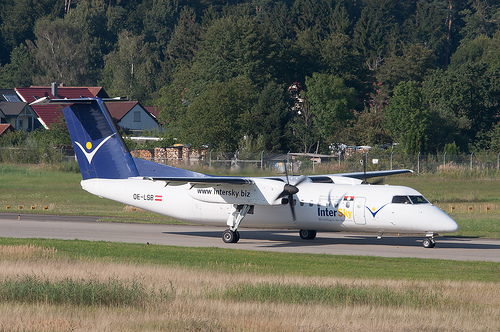Please provide the bounding box coordinate of the region this sentence describes: Brown and green grass beside airport runway. The bounding box coordinates for the 'Brown and green grass beside airport runway' are [0.03, 0.67, 0.65, 0.81]. This captures an area of mixed vegetation adjacent to the tarmac, providing a natural element within the airport environment. 